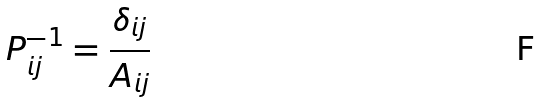Convert formula to latex. <formula><loc_0><loc_0><loc_500><loc_500>P _ { i j } ^ { - 1 } = \frac { \delta _ { i j } } { A _ { i j } }</formula> 